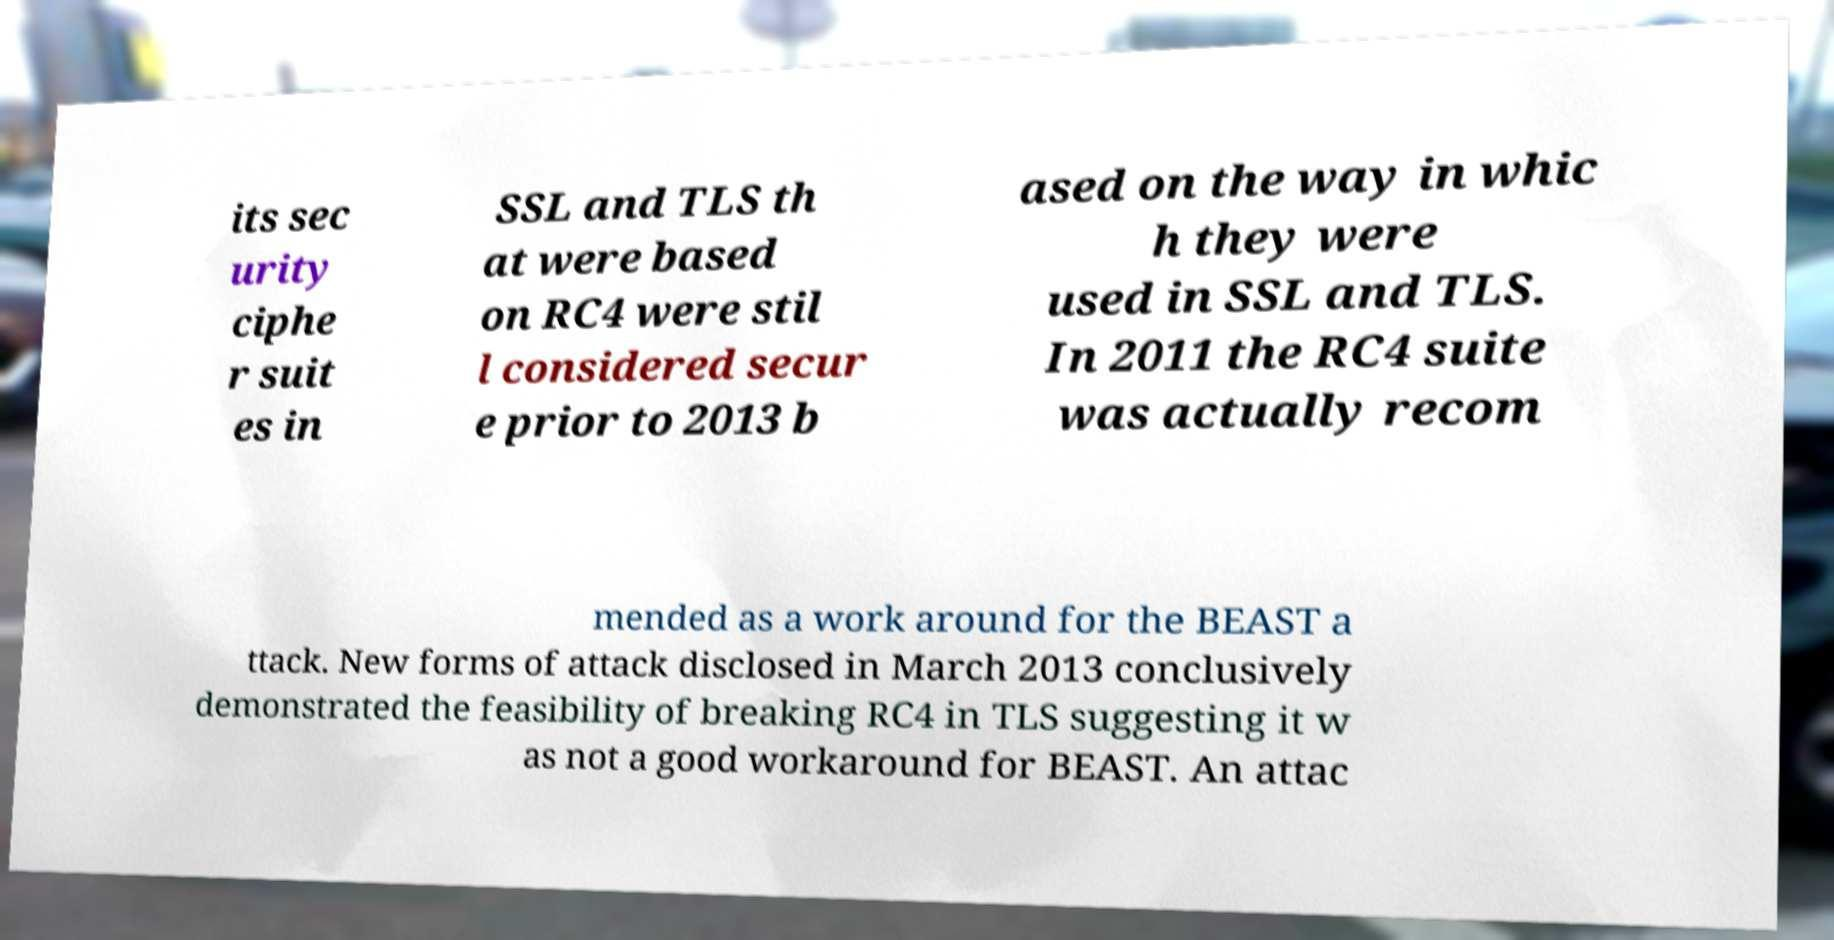Could you extract and type out the text from this image? its sec urity ciphe r suit es in SSL and TLS th at were based on RC4 were stil l considered secur e prior to 2013 b ased on the way in whic h they were used in SSL and TLS. In 2011 the RC4 suite was actually recom mended as a work around for the BEAST a ttack. New forms of attack disclosed in March 2013 conclusively demonstrated the feasibility of breaking RC4 in TLS suggesting it w as not a good workaround for BEAST. An attac 